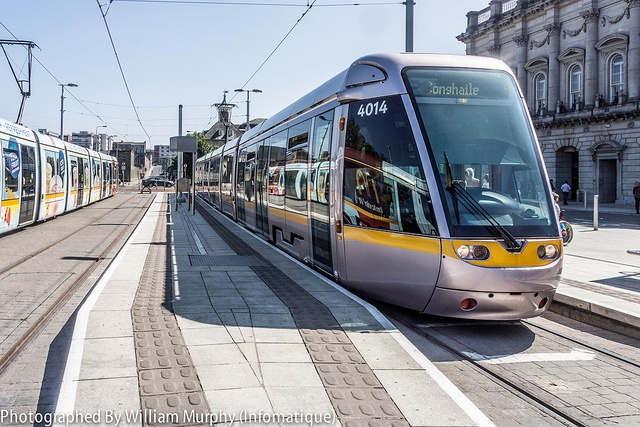Describe the objects in this image and their specific colors. I can see train in lightblue, black, gray, and darkgray tones, train in lightblue, white, gray, darkgray, and black tones, car in lightblue, black, gray, and darkgray tones, people in lightblue, gray, darkgray, and lightgray tones, and people in lightblue, black, gray, and navy tones in this image. 